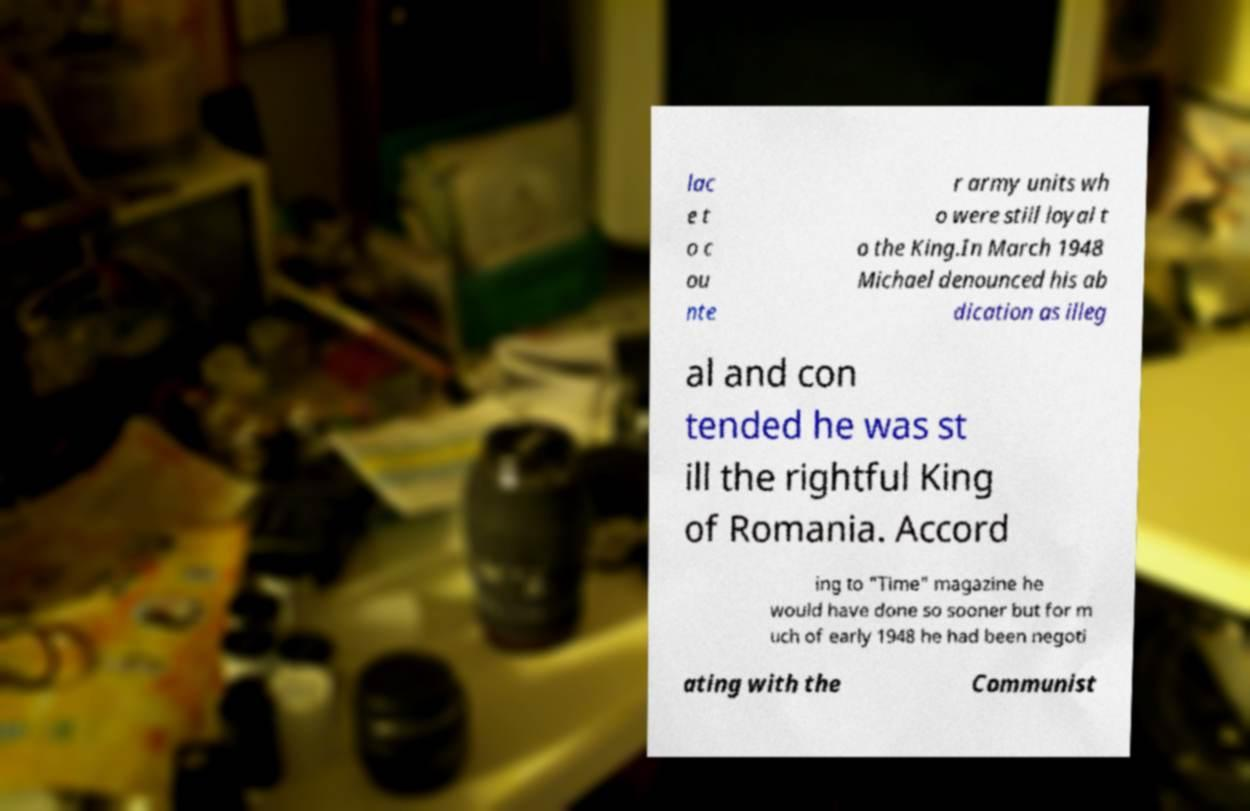Can you read and provide the text displayed in the image?This photo seems to have some interesting text. Can you extract and type it out for me? lac e t o c ou nte r army units wh o were still loyal t o the King.In March 1948 Michael denounced his ab dication as illeg al and con tended he was st ill the rightful King of Romania. Accord ing to "Time" magazine he would have done so sooner but for m uch of early 1948 he had been negoti ating with the Communist 